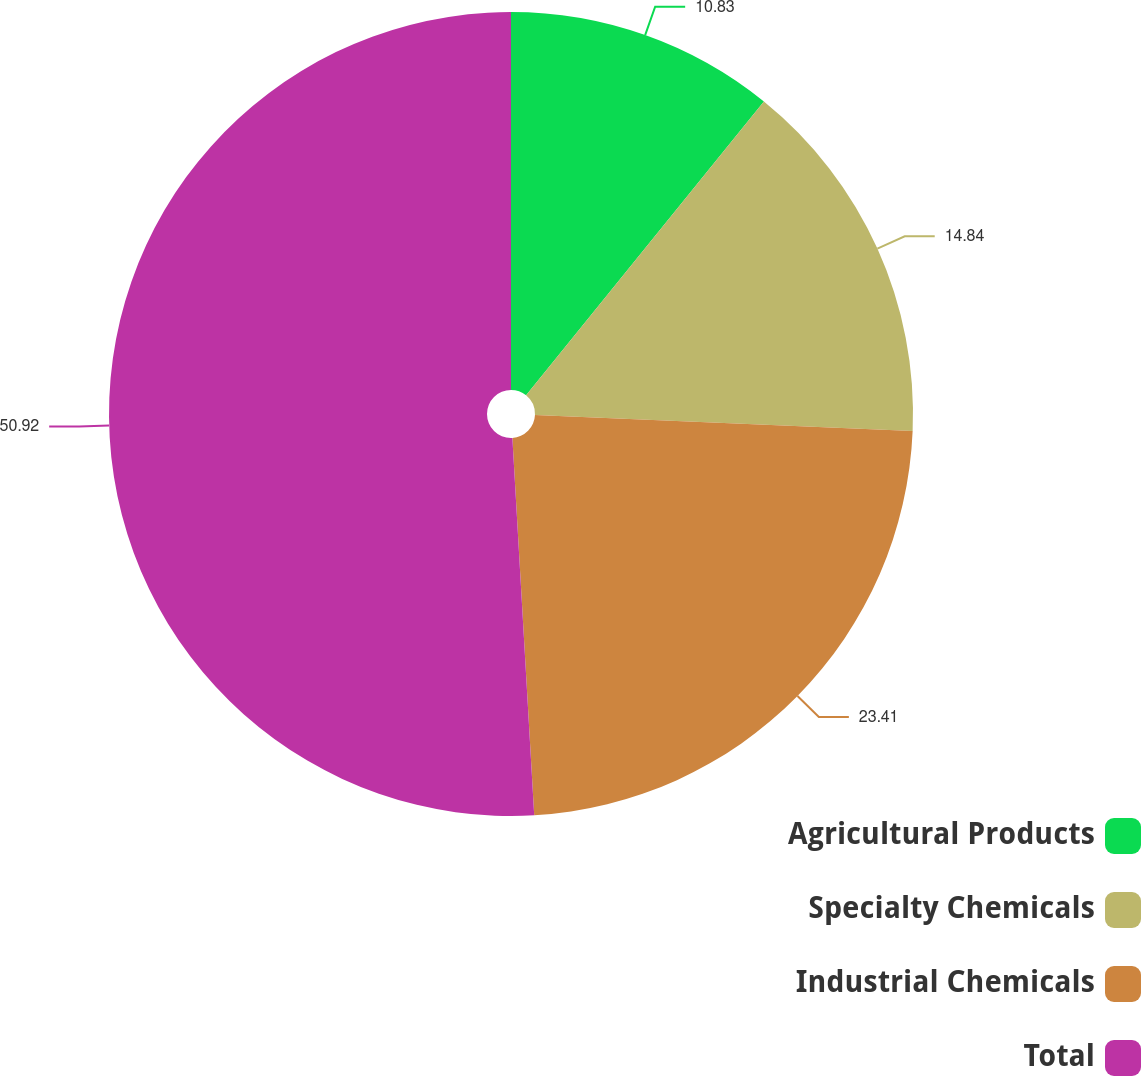Convert chart to OTSL. <chart><loc_0><loc_0><loc_500><loc_500><pie_chart><fcel>Agricultural Products<fcel>Specialty Chemicals<fcel>Industrial Chemicals<fcel>Total<nl><fcel>10.83%<fcel>14.84%<fcel>23.41%<fcel>50.92%<nl></chart> 